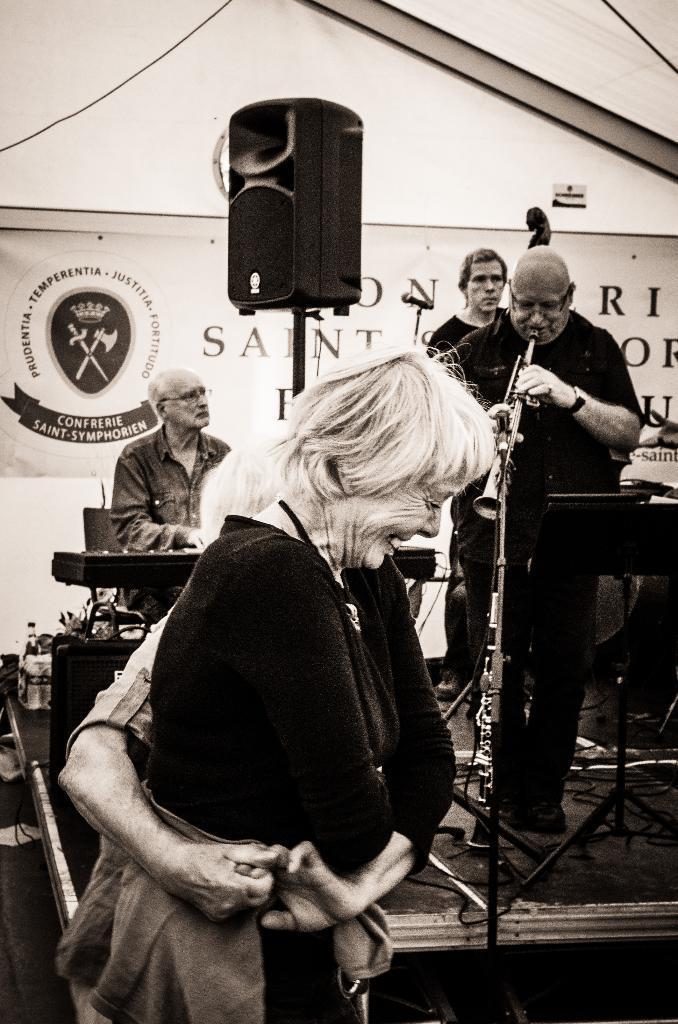Please provide a concise description of this image. In this picture there is a man and a woman in the center of the image, they are dancing and there is a stage behind them, there is a man who is standing on the stage, on the right side of the image, he is playing trumpet and there are other two men on the stage, there is a flex in the background area of the image. 